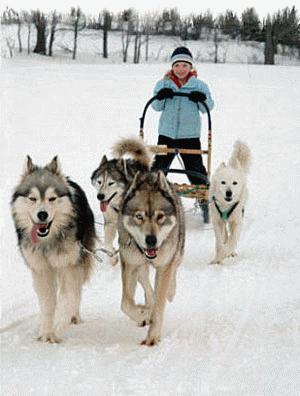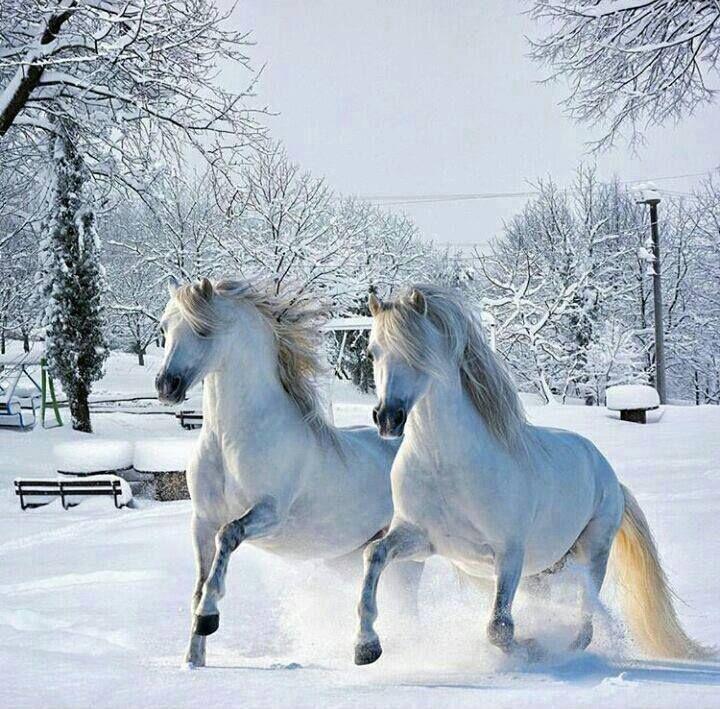The first image is the image on the left, the second image is the image on the right. Analyze the images presented: Is the assertion "One image shows dogs hitched to a sled with a driver standing behind it and moving in a forward direction." valid? Answer yes or no. Yes. 